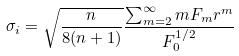<formula> <loc_0><loc_0><loc_500><loc_500>\sigma _ { i } = \sqrt { \frac { n } { 8 ( n + 1 ) } } \frac { \sum _ { m = 2 } ^ { \infty } m F _ { m } r ^ { m } } { F _ { 0 } ^ { 1 / 2 } }</formula> 